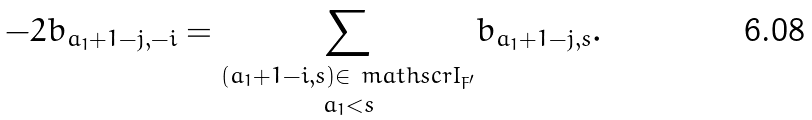Convert formula to latex. <formula><loc_0><loc_0><loc_500><loc_500>- 2 b _ { a _ { 1 } + 1 - j , - i } = \underset { a _ { 1 } < s } { \sum _ { ( a _ { 1 } + 1 - i , s ) \in \ m a t h s c r { I } _ { F ^ { \prime } } } } b _ { a _ { 1 } + 1 - j , s } .</formula> 